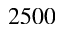<formula> <loc_0><loc_0><loc_500><loc_500>2 5 0 0</formula> 